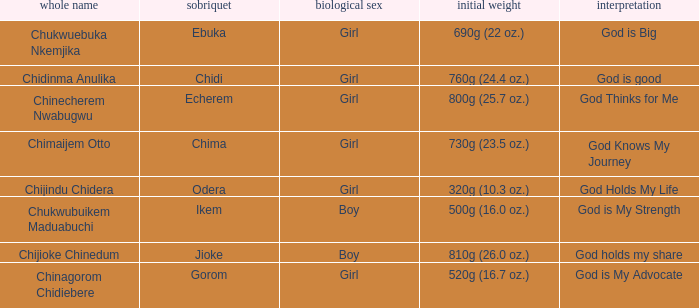What nickname has the meaning of God knows my journey? Chima. 